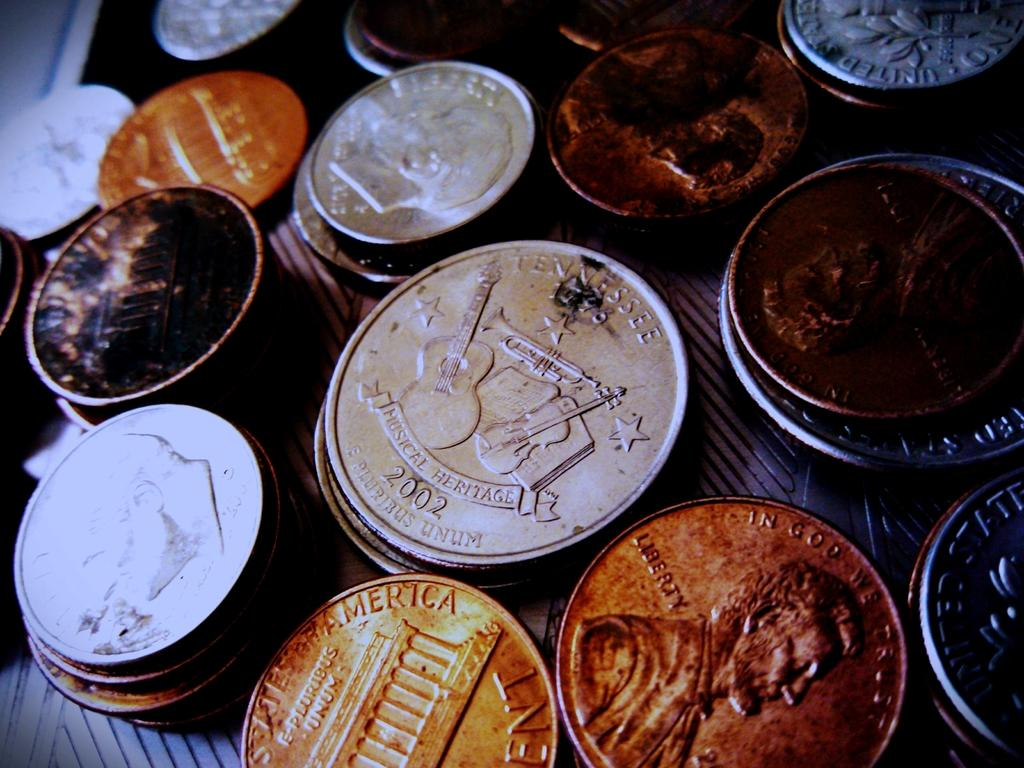What objects are present in the image? There are different types of coins in the image. Can you describe the appearance of the coins? The coins have different sizes, shapes, and designs. What might be the purpose of having these coins in the image? The coins could be used for collecting, studying, or displaying. How does the person in the image kick the coal? There is no person or coal present in the image; it only contains different types of coins. 